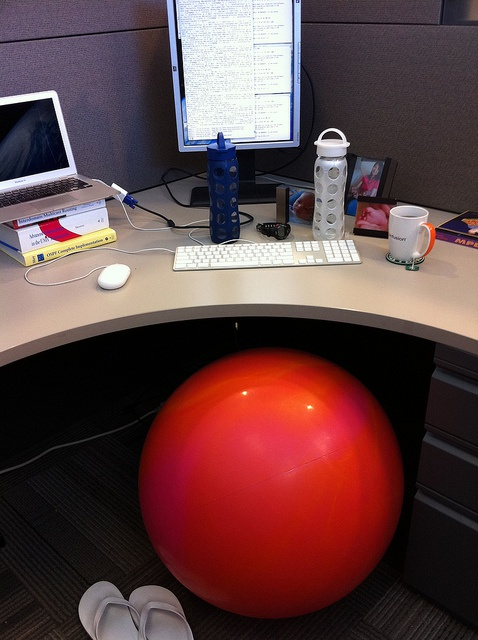Describe the objects in this image and their specific colors. I can see sports ball in purple, brown, maroon, red, and black tones, tv in purple, white, darkgray, black, and lavender tones, laptop in purple, black, lavender, darkgray, and gray tones, keyboard in purple, ivory, darkgray, lightgray, and gray tones, and bottle in purple, darkgray, lightgray, gray, and black tones in this image. 